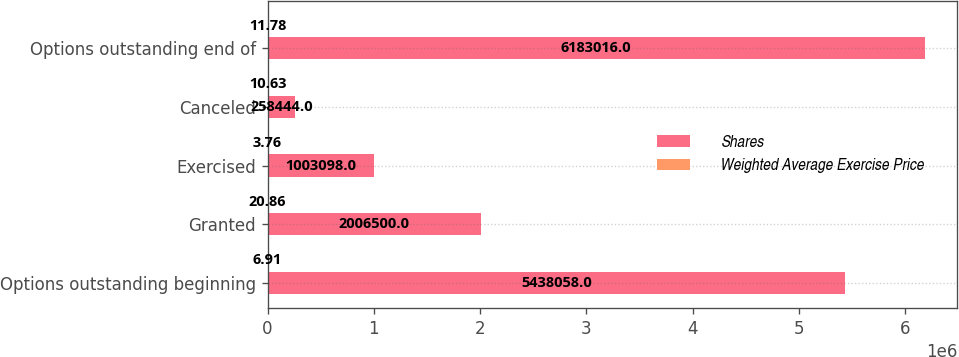<chart> <loc_0><loc_0><loc_500><loc_500><stacked_bar_chart><ecel><fcel>Options outstanding beginning<fcel>Granted<fcel>Exercised<fcel>Canceled<fcel>Options outstanding end of<nl><fcel>Shares<fcel>5.43806e+06<fcel>2.0065e+06<fcel>1.0031e+06<fcel>258444<fcel>6.18302e+06<nl><fcel>Weighted Average Exercise Price<fcel>6.91<fcel>20.86<fcel>3.76<fcel>10.63<fcel>11.78<nl></chart> 